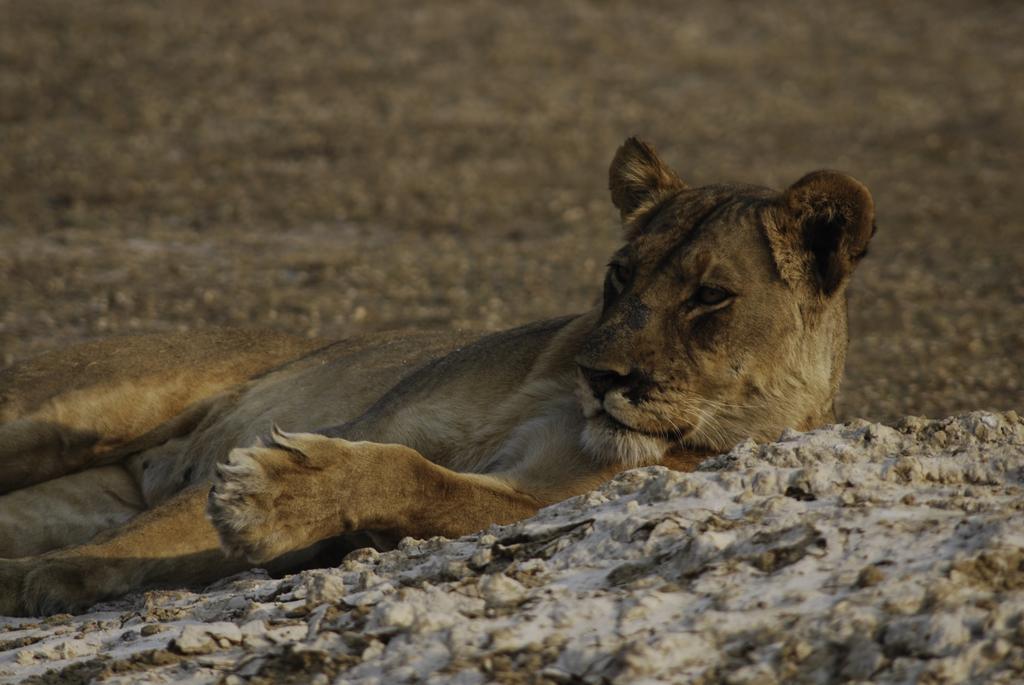Can you describe this image briefly? In this image, we can see a lion. We can also see the ground and some stones. 